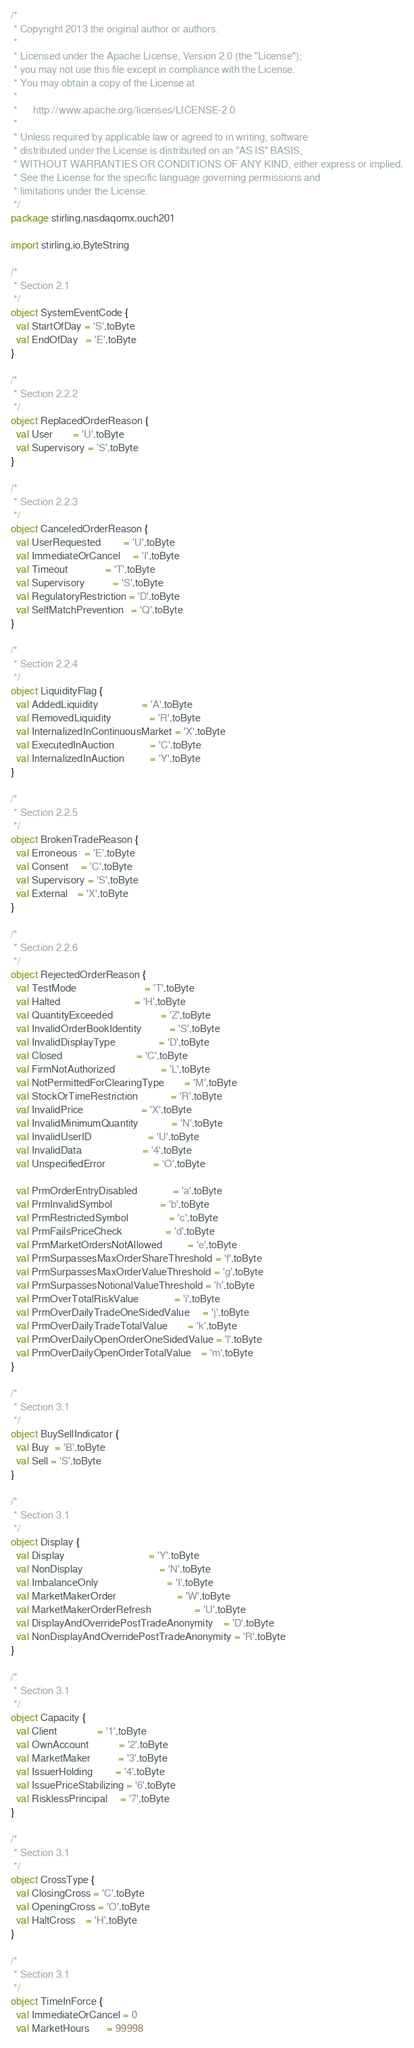<code> <loc_0><loc_0><loc_500><loc_500><_Scala_>/*
 * Copyright 2013 the original author or authors.
 *
 * Licensed under the Apache License, Version 2.0 (the "License");
 * you may not use this file except in compliance with the License.
 * You may obtain a copy of the License at
 *
 *      http://www.apache.org/licenses/LICENSE-2.0
 *
 * Unless required by applicable law or agreed to in writing, software
 * distributed under the License is distributed on an "AS IS" BASIS,
 * WITHOUT WARRANTIES OR CONDITIONS OF ANY KIND, either express or implied.
 * See the License for the specific language governing permissions and
 * limitations under the License.
 */
package stirling.nasdaqomx.ouch201

import stirling.io.ByteString

/*
 * Section 2.1
 */
object SystemEventCode {
  val StartOfDay = 'S'.toByte
  val EndOfDay   = 'E'.toByte
}

/*
 * Section 2.2.2
 */
object ReplacedOrderReason {
  val User        = 'U'.toByte
  val Supervisory = 'S'.toByte
}

/*
 * Section 2.2.3
 */
object CanceledOrderReason {
  val UserRequested         = 'U'.toByte
  val ImmediateOrCancel     = 'I'.toByte
  val Timeout               = 'T'.toByte
  val Supervisory           = 'S'.toByte
  val RegulatoryRestriction = 'D'.toByte
  val SelfMatchPrevention   = 'Q'.toByte
}

/*
 * Section 2.2.4
 */
object LiquidityFlag {
  val AddedLiquidity                 = 'A'.toByte
  val RemovedLiquidity               = 'R'.toByte
  val InternalizedInContinuousMarket = 'X'.toByte
  val ExecutedInAuction              = 'C'.toByte
  val InternalizedInAuction          = 'Y'.toByte
}

/*
 * Section 2.2.5
 */
object BrokenTradeReason {
  val Erroneous   = 'E'.toByte
  val Consent     = 'C'.toByte
  val Supervisory = 'S'.toByte
  val External    = 'X'.toByte
}

/*
 * Section 2.2.6
 */
object RejectedOrderReason {
  val TestMode                           = 'T'.toByte
  val Halted                             = 'H'.toByte
  val QuantityExceeded                   = 'Z'.toByte
  val InvalidOrderBookIdentity           = 'S'.toByte
  val InvalidDisplayType                 = 'D'.toByte
  val Closed                             = 'C'.toByte
  val FirmNotAuthorized                  = 'L'.toByte
  val NotPermittedForClearingType        = 'M'.toByte
  val StockOrTimeRestriction             = 'R'.toByte
  val InvalidPrice                       = 'X'.toByte
  val InvalidMinimumQuantity             = 'N'.toByte
  val InvalidUserID                      = 'U'.toByte
  val InvalidData                        = '4'.toByte
  val UnspecifiedError                   = 'O'.toByte

  val PrmOrderEntryDisabled              = 'a'.toByte
  val PrmInvalidSymbol                   = 'b'.toByte
  val PrmRestrictedSymbol                = 'c'.toByte
  val PrmFailsPriceCheck                 = 'd'.toByte
  val PrmMarketOrdersNotAllowed          = 'e'.toByte
  val PrmSurpassesMaxOrderShareThreshold = 'f'.toByte
  val PrmSurpassesMaxOrderValueThreshold = 'g'.toByte
  val PrmSurpassesNotionalValueThreshold = 'h'.toByte
  val PrmOverTotalRiskValue              = 'i'.toByte
  val PrmOverDailyTradeOneSidedValue     = 'j'.toByte
  val PrmOverDailyTradeTotalValue        = 'k'.toByte
  val PrmOverDailyOpenOrderOneSidedValue = 'l'.toByte
  val PrmOverDailyOpenOrderTotalValue    = 'm'.toByte
}

/*
 * Section 3.1
 */
object BuySellIndicator {
  val Buy  = 'B'.toByte
  val Sell = 'S'.toByte
}

/*
 * Section 3.1
 */
object Display {
  val Display                                 = 'Y'.toByte
  val NonDisplay                              = 'N'.toByte
  val ImbalanceOnly                           = 'I'.toByte
  val MarketMakerOrder                        = 'W'.toByte
  val MarketMakerOrderRefresh                 = 'U'.toByte
  val DisplayAndOverridePostTradeAnonymity    = 'D'.toByte
  val NonDisplayAndOverridePostTradeAnonymity = 'R'.toByte
}

/*
 * Section 3.1
 */
object Capacity {
  val Client                = '1'.toByte
  val OwnAccount            = '2'.toByte
  val MarketMaker           = '3'.toByte
  val IssuerHolding         = '4'.toByte
  val IssuePriceStabilizing = '6'.toByte
  val RisklessPrincipal     = '7'.toByte
}

/*
 * Section 3.1
 */
object CrossType {
  val ClosingCross = 'C'.toByte
  val OpeningCross = 'O'.toByte
  val HaltCross    = 'H'.toByte
}

/*
 * Section 3.1
 */
object TimeInForce {
  val ImmediateOrCancel = 0
  val MarketHours       = 99998</code> 